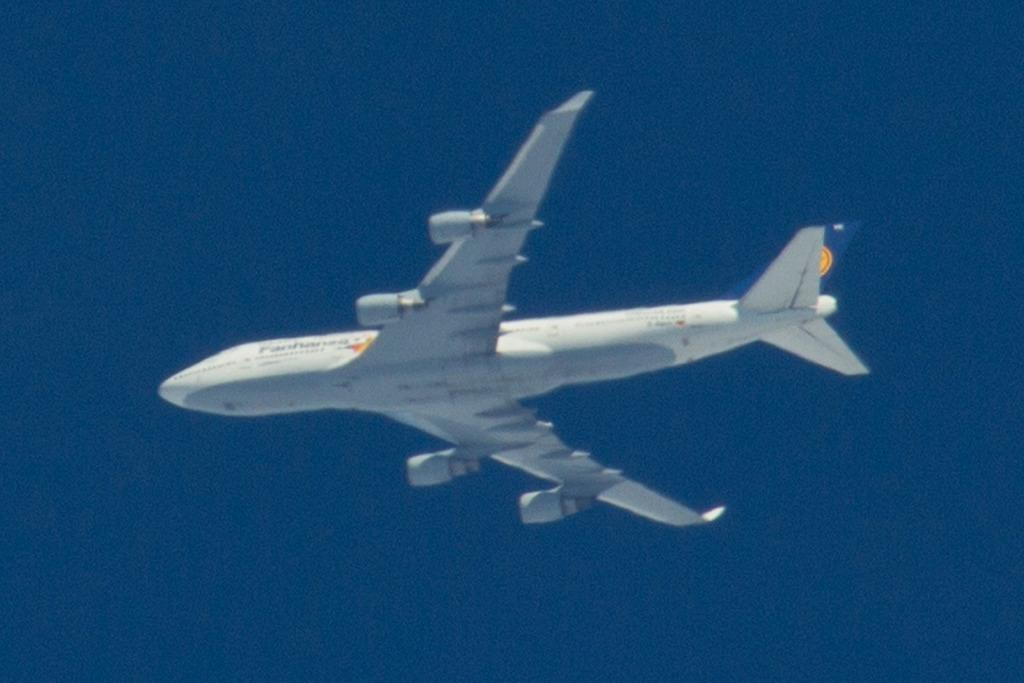What is the main subject of the image? The main subject of the image is an airplane. What is the airplane doing in the image? The airplane is flying in the sky. Can you see a gun being fired from the airplane in the image? There is no gun or any indication of a gun being fired in the image; it only features an airplane flying in the sky. 